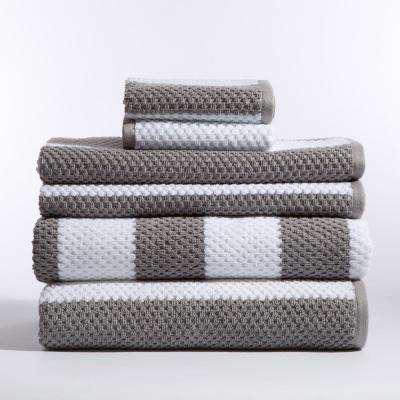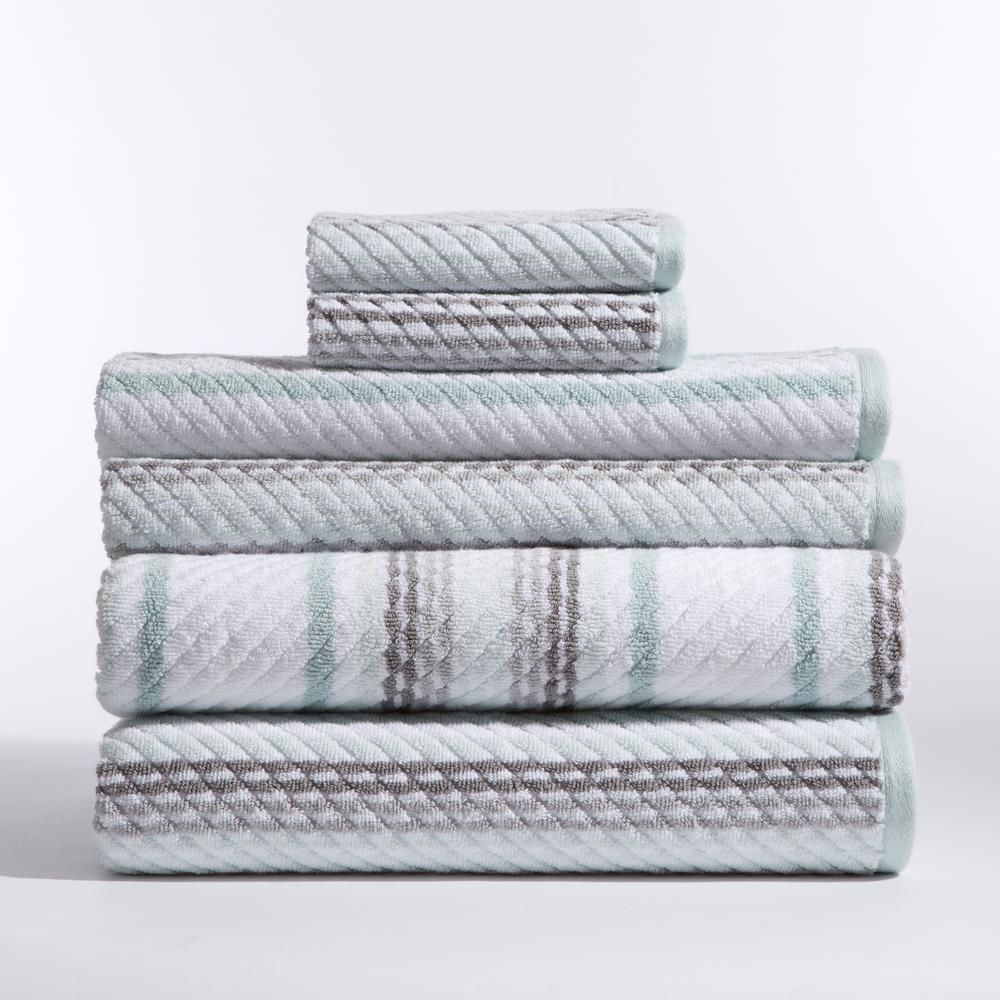The first image is the image on the left, the second image is the image on the right. For the images displayed, is the sentence "There are more items in the left image than in the right image." factually correct? Answer yes or no. No. The first image is the image on the left, the second image is the image on the right. Examine the images to the left and right. Is the description "The left and right image contains a total of nine towels." accurate? Answer yes or no. No. 